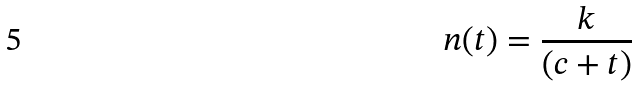Convert formula to latex. <formula><loc_0><loc_0><loc_500><loc_500>n ( t ) = \frac { k } { ( c + t ) }</formula> 